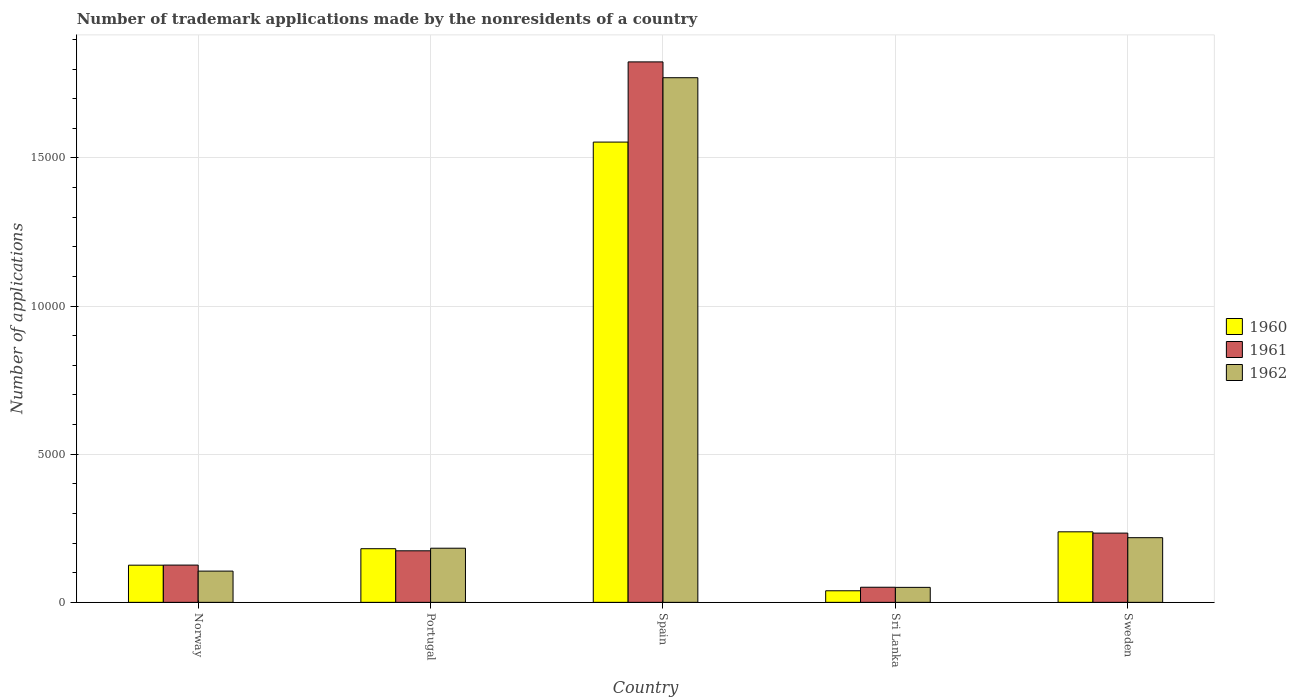How many different coloured bars are there?
Give a very brief answer. 3. How many groups of bars are there?
Offer a very short reply. 5. How many bars are there on the 5th tick from the left?
Keep it short and to the point. 3. How many bars are there on the 4th tick from the right?
Provide a succinct answer. 3. What is the number of trademark applications made by the nonresidents in 1962 in Sri Lanka?
Provide a short and direct response. 506. Across all countries, what is the maximum number of trademark applications made by the nonresidents in 1961?
Offer a terse response. 1.82e+04. Across all countries, what is the minimum number of trademark applications made by the nonresidents in 1961?
Your answer should be very brief. 510. In which country was the number of trademark applications made by the nonresidents in 1961 maximum?
Offer a very short reply. Spain. In which country was the number of trademark applications made by the nonresidents in 1962 minimum?
Your answer should be very brief. Sri Lanka. What is the total number of trademark applications made by the nonresidents in 1961 in the graph?
Your answer should be compact. 2.41e+04. What is the difference between the number of trademark applications made by the nonresidents in 1960 in Norway and that in Sweden?
Keep it short and to the point. -1126. What is the difference between the number of trademark applications made by the nonresidents in 1960 in Norway and the number of trademark applications made by the nonresidents in 1961 in Sweden?
Offer a very short reply. -1083. What is the average number of trademark applications made by the nonresidents in 1960 per country?
Give a very brief answer. 4275. What is the difference between the number of trademark applications made by the nonresidents of/in 1961 and number of trademark applications made by the nonresidents of/in 1960 in Portugal?
Offer a very short reply. -71. In how many countries, is the number of trademark applications made by the nonresidents in 1962 greater than 14000?
Offer a very short reply. 1. What is the ratio of the number of trademark applications made by the nonresidents in 1960 in Portugal to that in Sri Lanka?
Your answer should be very brief. 4.63. Is the difference between the number of trademark applications made by the nonresidents in 1961 in Portugal and Sweden greater than the difference between the number of trademark applications made by the nonresidents in 1960 in Portugal and Sweden?
Offer a terse response. No. What is the difference between the highest and the second highest number of trademark applications made by the nonresidents in 1961?
Offer a very short reply. 598. What is the difference between the highest and the lowest number of trademark applications made by the nonresidents in 1961?
Give a very brief answer. 1.77e+04. Is the sum of the number of trademark applications made by the nonresidents in 1960 in Spain and Sri Lanka greater than the maximum number of trademark applications made by the nonresidents in 1962 across all countries?
Offer a terse response. No. What does the 3rd bar from the left in Sri Lanka represents?
Your answer should be very brief. 1962. Is it the case that in every country, the sum of the number of trademark applications made by the nonresidents in 1962 and number of trademark applications made by the nonresidents in 1961 is greater than the number of trademark applications made by the nonresidents in 1960?
Your answer should be compact. Yes. How many countries are there in the graph?
Keep it short and to the point. 5. What is the difference between two consecutive major ticks on the Y-axis?
Offer a terse response. 5000. Are the values on the major ticks of Y-axis written in scientific E-notation?
Your response must be concise. No. How many legend labels are there?
Keep it short and to the point. 3. What is the title of the graph?
Offer a very short reply. Number of trademark applications made by the nonresidents of a country. What is the label or title of the X-axis?
Offer a very short reply. Country. What is the label or title of the Y-axis?
Keep it short and to the point. Number of applications. What is the Number of applications in 1960 in Norway?
Give a very brief answer. 1255. What is the Number of applications of 1961 in Norway?
Give a very brief answer. 1258. What is the Number of applications of 1962 in Norway?
Offer a very short reply. 1055. What is the Number of applications of 1960 in Portugal?
Offer a very short reply. 1811. What is the Number of applications in 1961 in Portugal?
Provide a short and direct response. 1740. What is the Number of applications in 1962 in Portugal?
Offer a very short reply. 1828. What is the Number of applications in 1960 in Spain?
Your answer should be very brief. 1.55e+04. What is the Number of applications in 1961 in Spain?
Ensure brevity in your answer.  1.82e+04. What is the Number of applications in 1962 in Spain?
Your answer should be very brief. 1.77e+04. What is the Number of applications of 1960 in Sri Lanka?
Offer a terse response. 391. What is the Number of applications in 1961 in Sri Lanka?
Your response must be concise. 510. What is the Number of applications in 1962 in Sri Lanka?
Make the answer very short. 506. What is the Number of applications of 1960 in Sweden?
Your answer should be compact. 2381. What is the Number of applications of 1961 in Sweden?
Offer a terse response. 2338. What is the Number of applications in 1962 in Sweden?
Give a very brief answer. 2183. Across all countries, what is the maximum Number of applications in 1960?
Your answer should be very brief. 1.55e+04. Across all countries, what is the maximum Number of applications in 1961?
Provide a succinct answer. 1.82e+04. Across all countries, what is the maximum Number of applications of 1962?
Your response must be concise. 1.77e+04. Across all countries, what is the minimum Number of applications of 1960?
Provide a short and direct response. 391. Across all countries, what is the minimum Number of applications of 1961?
Your answer should be very brief. 510. Across all countries, what is the minimum Number of applications in 1962?
Make the answer very short. 506. What is the total Number of applications in 1960 in the graph?
Give a very brief answer. 2.14e+04. What is the total Number of applications of 1961 in the graph?
Give a very brief answer. 2.41e+04. What is the total Number of applications in 1962 in the graph?
Give a very brief answer. 2.33e+04. What is the difference between the Number of applications of 1960 in Norway and that in Portugal?
Ensure brevity in your answer.  -556. What is the difference between the Number of applications of 1961 in Norway and that in Portugal?
Provide a short and direct response. -482. What is the difference between the Number of applications in 1962 in Norway and that in Portugal?
Offer a very short reply. -773. What is the difference between the Number of applications in 1960 in Norway and that in Spain?
Keep it short and to the point. -1.43e+04. What is the difference between the Number of applications in 1961 in Norway and that in Spain?
Make the answer very short. -1.70e+04. What is the difference between the Number of applications in 1962 in Norway and that in Spain?
Your answer should be very brief. -1.67e+04. What is the difference between the Number of applications of 1960 in Norway and that in Sri Lanka?
Your answer should be compact. 864. What is the difference between the Number of applications of 1961 in Norway and that in Sri Lanka?
Your response must be concise. 748. What is the difference between the Number of applications in 1962 in Norway and that in Sri Lanka?
Provide a succinct answer. 549. What is the difference between the Number of applications in 1960 in Norway and that in Sweden?
Provide a short and direct response. -1126. What is the difference between the Number of applications in 1961 in Norway and that in Sweden?
Your response must be concise. -1080. What is the difference between the Number of applications of 1962 in Norway and that in Sweden?
Offer a terse response. -1128. What is the difference between the Number of applications of 1960 in Portugal and that in Spain?
Keep it short and to the point. -1.37e+04. What is the difference between the Number of applications of 1961 in Portugal and that in Spain?
Offer a terse response. -1.65e+04. What is the difference between the Number of applications of 1962 in Portugal and that in Spain?
Make the answer very short. -1.59e+04. What is the difference between the Number of applications of 1960 in Portugal and that in Sri Lanka?
Offer a very short reply. 1420. What is the difference between the Number of applications in 1961 in Portugal and that in Sri Lanka?
Provide a succinct answer. 1230. What is the difference between the Number of applications in 1962 in Portugal and that in Sri Lanka?
Make the answer very short. 1322. What is the difference between the Number of applications of 1960 in Portugal and that in Sweden?
Provide a short and direct response. -570. What is the difference between the Number of applications in 1961 in Portugal and that in Sweden?
Your answer should be compact. -598. What is the difference between the Number of applications in 1962 in Portugal and that in Sweden?
Your response must be concise. -355. What is the difference between the Number of applications of 1960 in Spain and that in Sri Lanka?
Provide a succinct answer. 1.51e+04. What is the difference between the Number of applications in 1961 in Spain and that in Sri Lanka?
Ensure brevity in your answer.  1.77e+04. What is the difference between the Number of applications of 1962 in Spain and that in Sri Lanka?
Give a very brief answer. 1.72e+04. What is the difference between the Number of applications of 1960 in Spain and that in Sweden?
Keep it short and to the point. 1.32e+04. What is the difference between the Number of applications in 1961 in Spain and that in Sweden?
Give a very brief answer. 1.59e+04. What is the difference between the Number of applications in 1962 in Spain and that in Sweden?
Ensure brevity in your answer.  1.55e+04. What is the difference between the Number of applications of 1960 in Sri Lanka and that in Sweden?
Give a very brief answer. -1990. What is the difference between the Number of applications in 1961 in Sri Lanka and that in Sweden?
Ensure brevity in your answer.  -1828. What is the difference between the Number of applications in 1962 in Sri Lanka and that in Sweden?
Provide a short and direct response. -1677. What is the difference between the Number of applications of 1960 in Norway and the Number of applications of 1961 in Portugal?
Provide a succinct answer. -485. What is the difference between the Number of applications of 1960 in Norway and the Number of applications of 1962 in Portugal?
Provide a succinct answer. -573. What is the difference between the Number of applications in 1961 in Norway and the Number of applications in 1962 in Portugal?
Give a very brief answer. -570. What is the difference between the Number of applications in 1960 in Norway and the Number of applications in 1961 in Spain?
Provide a succinct answer. -1.70e+04. What is the difference between the Number of applications in 1960 in Norway and the Number of applications in 1962 in Spain?
Give a very brief answer. -1.65e+04. What is the difference between the Number of applications in 1961 in Norway and the Number of applications in 1962 in Spain?
Provide a short and direct response. -1.65e+04. What is the difference between the Number of applications in 1960 in Norway and the Number of applications in 1961 in Sri Lanka?
Offer a terse response. 745. What is the difference between the Number of applications of 1960 in Norway and the Number of applications of 1962 in Sri Lanka?
Offer a very short reply. 749. What is the difference between the Number of applications of 1961 in Norway and the Number of applications of 1962 in Sri Lanka?
Give a very brief answer. 752. What is the difference between the Number of applications in 1960 in Norway and the Number of applications in 1961 in Sweden?
Ensure brevity in your answer.  -1083. What is the difference between the Number of applications of 1960 in Norway and the Number of applications of 1962 in Sweden?
Provide a short and direct response. -928. What is the difference between the Number of applications in 1961 in Norway and the Number of applications in 1962 in Sweden?
Offer a very short reply. -925. What is the difference between the Number of applications of 1960 in Portugal and the Number of applications of 1961 in Spain?
Provide a short and direct response. -1.64e+04. What is the difference between the Number of applications in 1960 in Portugal and the Number of applications in 1962 in Spain?
Offer a terse response. -1.59e+04. What is the difference between the Number of applications in 1961 in Portugal and the Number of applications in 1962 in Spain?
Provide a short and direct response. -1.60e+04. What is the difference between the Number of applications in 1960 in Portugal and the Number of applications in 1961 in Sri Lanka?
Keep it short and to the point. 1301. What is the difference between the Number of applications in 1960 in Portugal and the Number of applications in 1962 in Sri Lanka?
Your answer should be compact. 1305. What is the difference between the Number of applications of 1961 in Portugal and the Number of applications of 1962 in Sri Lanka?
Ensure brevity in your answer.  1234. What is the difference between the Number of applications of 1960 in Portugal and the Number of applications of 1961 in Sweden?
Provide a succinct answer. -527. What is the difference between the Number of applications in 1960 in Portugal and the Number of applications in 1962 in Sweden?
Provide a succinct answer. -372. What is the difference between the Number of applications in 1961 in Portugal and the Number of applications in 1962 in Sweden?
Ensure brevity in your answer.  -443. What is the difference between the Number of applications of 1960 in Spain and the Number of applications of 1961 in Sri Lanka?
Make the answer very short. 1.50e+04. What is the difference between the Number of applications in 1960 in Spain and the Number of applications in 1962 in Sri Lanka?
Your answer should be very brief. 1.50e+04. What is the difference between the Number of applications in 1961 in Spain and the Number of applications in 1962 in Sri Lanka?
Ensure brevity in your answer.  1.77e+04. What is the difference between the Number of applications in 1960 in Spain and the Number of applications in 1961 in Sweden?
Provide a short and direct response. 1.32e+04. What is the difference between the Number of applications of 1960 in Spain and the Number of applications of 1962 in Sweden?
Offer a very short reply. 1.34e+04. What is the difference between the Number of applications of 1961 in Spain and the Number of applications of 1962 in Sweden?
Provide a short and direct response. 1.61e+04. What is the difference between the Number of applications in 1960 in Sri Lanka and the Number of applications in 1961 in Sweden?
Your response must be concise. -1947. What is the difference between the Number of applications of 1960 in Sri Lanka and the Number of applications of 1962 in Sweden?
Ensure brevity in your answer.  -1792. What is the difference between the Number of applications of 1961 in Sri Lanka and the Number of applications of 1962 in Sweden?
Give a very brief answer. -1673. What is the average Number of applications of 1960 per country?
Offer a terse response. 4275. What is the average Number of applications of 1961 per country?
Your answer should be compact. 4818. What is the average Number of applications of 1962 per country?
Offer a terse response. 4656.4. What is the difference between the Number of applications in 1960 and Number of applications in 1961 in Norway?
Ensure brevity in your answer.  -3. What is the difference between the Number of applications in 1960 and Number of applications in 1962 in Norway?
Provide a succinct answer. 200. What is the difference between the Number of applications of 1961 and Number of applications of 1962 in Norway?
Make the answer very short. 203. What is the difference between the Number of applications of 1960 and Number of applications of 1961 in Portugal?
Give a very brief answer. 71. What is the difference between the Number of applications of 1960 and Number of applications of 1962 in Portugal?
Make the answer very short. -17. What is the difference between the Number of applications in 1961 and Number of applications in 1962 in Portugal?
Provide a short and direct response. -88. What is the difference between the Number of applications in 1960 and Number of applications in 1961 in Spain?
Offer a very short reply. -2707. What is the difference between the Number of applications of 1960 and Number of applications of 1962 in Spain?
Offer a very short reply. -2173. What is the difference between the Number of applications of 1961 and Number of applications of 1962 in Spain?
Ensure brevity in your answer.  534. What is the difference between the Number of applications of 1960 and Number of applications of 1961 in Sri Lanka?
Your response must be concise. -119. What is the difference between the Number of applications in 1960 and Number of applications in 1962 in Sri Lanka?
Your answer should be very brief. -115. What is the difference between the Number of applications in 1960 and Number of applications in 1962 in Sweden?
Give a very brief answer. 198. What is the difference between the Number of applications of 1961 and Number of applications of 1962 in Sweden?
Keep it short and to the point. 155. What is the ratio of the Number of applications in 1960 in Norway to that in Portugal?
Keep it short and to the point. 0.69. What is the ratio of the Number of applications of 1961 in Norway to that in Portugal?
Your answer should be very brief. 0.72. What is the ratio of the Number of applications of 1962 in Norway to that in Portugal?
Ensure brevity in your answer.  0.58. What is the ratio of the Number of applications of 1960 in Norway to that in Spain?
Provide a succinct answer. 0.08. What is the ratio of the Number of applications in 1961 in Norway to that in Spain?
Ensure brevity in your answer.  0.07. What is the ratio of the Number of applications of 1962 in Norway to that in Spain?
Offer a terse response. 0.06. What is the ratio of the Number of applications of 1960 in Norway to that in Sri Lanka?
Provide a short and direct response. 3.21. What is the ratio of the Number of applications in 1961 in Norway to that in Sri Lanka?
Your response must be concise. 2.47. What is the ratio of the Number of applications of 1962 in Norway to that in Sri Lanka?
Provide a short and direct response. 2.08. What is the ratio of the Number of applications of 1960 in Norway to that in Sweden?
Your answer should be very brief. 0.53. What is the ratio of the Number of applications in 1961 in Norway to that in Sweden?
Your answer should be very brief. 0.54. What is the ratio of the Number of applications of 1962 in Norway to that in Sweden?
Your answer should be compact. 0.48. What is the ratio of the Number of applications in 1960 in Portugal to that in Spain?
Your answer should be compact. 0.12. What is the ratio of the Number of applications of 1961 in Portugal to that in Spain?
Provide a short and direct response. 0.1. What is the ratio of the Number of applications in 1962 in Portugal to that in Spain?
Offer a terse response. 0.1. What is the ratio of the Number of applications of 1960 in Portugal to that in Sri Lanka?
Offer a very short reply. 4.63. What is the ratio of the Number of applications of 1961 in Portugal to that in Sri Lanka?
Provide a succinct answer. 3.41. What is the ratio of the Number of applications of 1962 in Portugal to that in Sri Lanka?
Your answer should be compact. 3.61. What is the ratio of the Number of applications of 1960 in Portugal to that in Sweden?
Your response must be concise. 0.76. What is the ratio of the Number of applications of 1961 in Portugal to that in Sweden?
Make the answer very short. 0.74. What is the ratio of the Number of applications of 1962 in Portugal to that in Sweden?
Offer a terse response. 0.84. What is the ratio of the Number of applications in 1960 in Spain to that in Sri Lanka?
Provide a succinct answer. 39.74. What is the ratio of the Number of applications in 1961 in Spain to that in Sri Lanka?
Provide a short and direct response. 35.77. What is the ratio of the Number of applications in 1962 in Spain to that in Sri Lanka?
Provide a short and direct response. 35. What is the ratio of the Number of applications of 1960 in Spain to that in Sweden?
Offer a very short reply. 6.53. What is the ratio of the Number of applications in 1961 in Spain to that in Sweden?
Your answer should be very brief. 7.8. What is the ratio of the Number of applications of 1962 in Spain to that in Sweden?
Ensure brevity in your answer.  8.11. What is the ratio of the Number of applications of 1960 in Sri Lanka to that in Sweden?
Provide a succinct answer. 0.16. What is the ratio of the Number of applications of 1961 in Sri Lanka to that in Sweden?
Give a very brief answer. 0.22. What is the ratio of the Number of applications in 1962 in Sri Lanka to that in Sweden?
Your answer should be compact. 0.23. What is the difference between the highest and the second highest Number of applications of 1960?
Keep it short and to the point. 1.32e+04. What is the difference between the highest and the second highest Number of applications of 1961?
Your answer should be very brief. 1.59e+04. What is the difference between the highest and the second highest Number of applications in 1962?
Keep it short and to the point. 1.55e+04. What is the difference between the highest and the lowest Number of applications in 1960?
Your answer should be very brief. 1.51e+04. What is the difference between the highest and the lowest Number of applications of 1961?
Give a very brief answer. 1.77e+04. What is the difference between the highest and the lowest Number of applications of 1962?
Your answer should be very brief. 1.72e+04. 